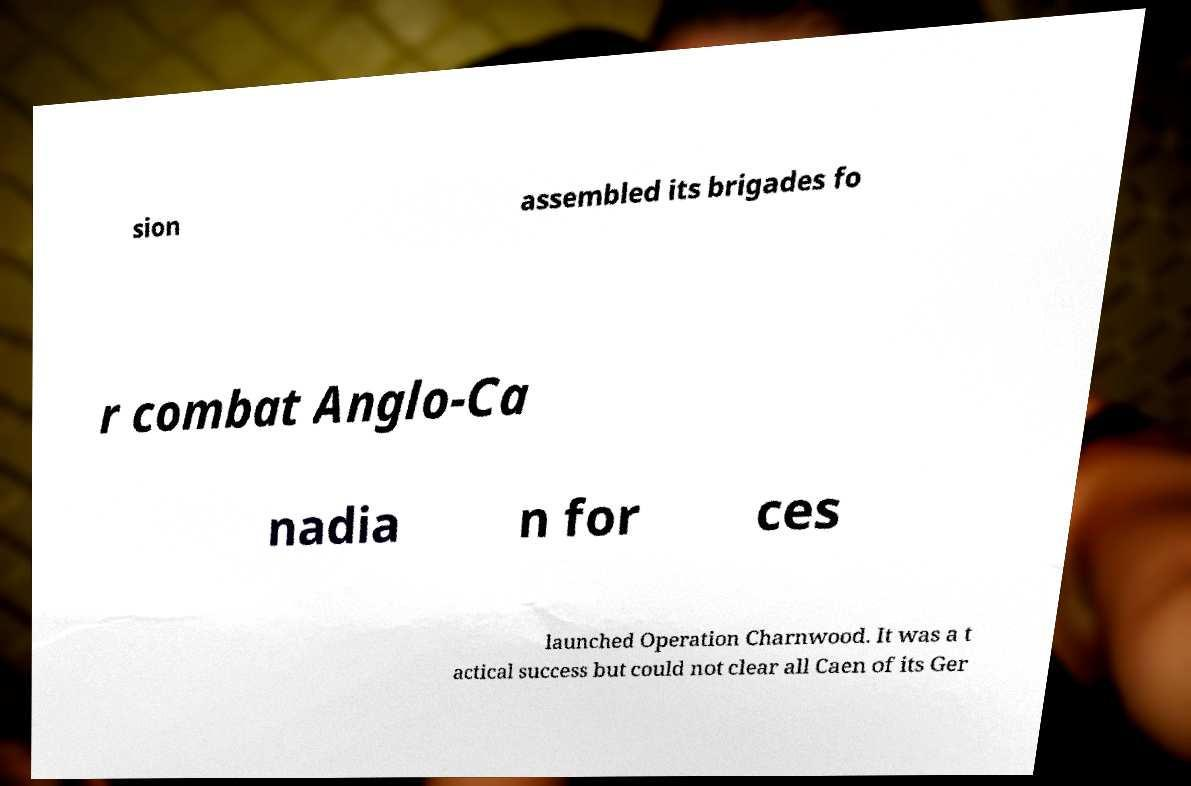I need the written content from this picture converted into text. Can you do that? sion assembled its brigades fo r combat Anglo-Ca nadia n for ces launched Operation Charnwood. It was a t actical success but could not clear all Caen of its Ger 